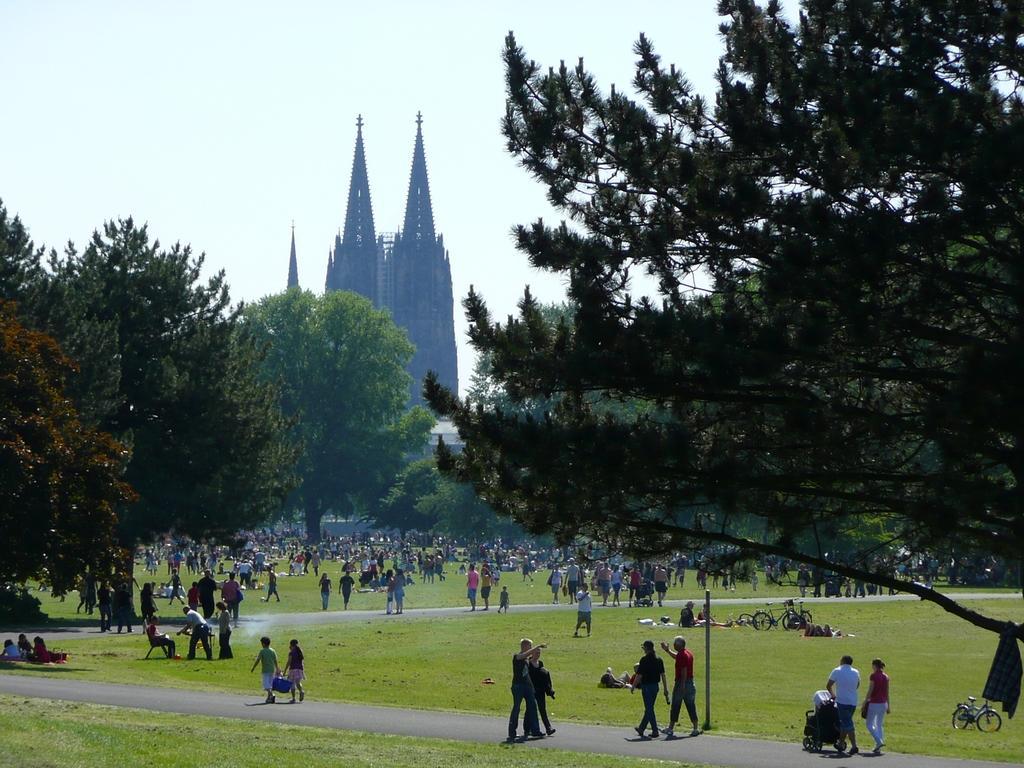Could you give a brief overview of what you see in this image? In this picture there is a building and there are trees and there are group of people walking and there are group of people sitting. On the right side of the image there are bicycles and there are objects on the grass. At the top there is sky. At the bottom there is a road and there is grass. 